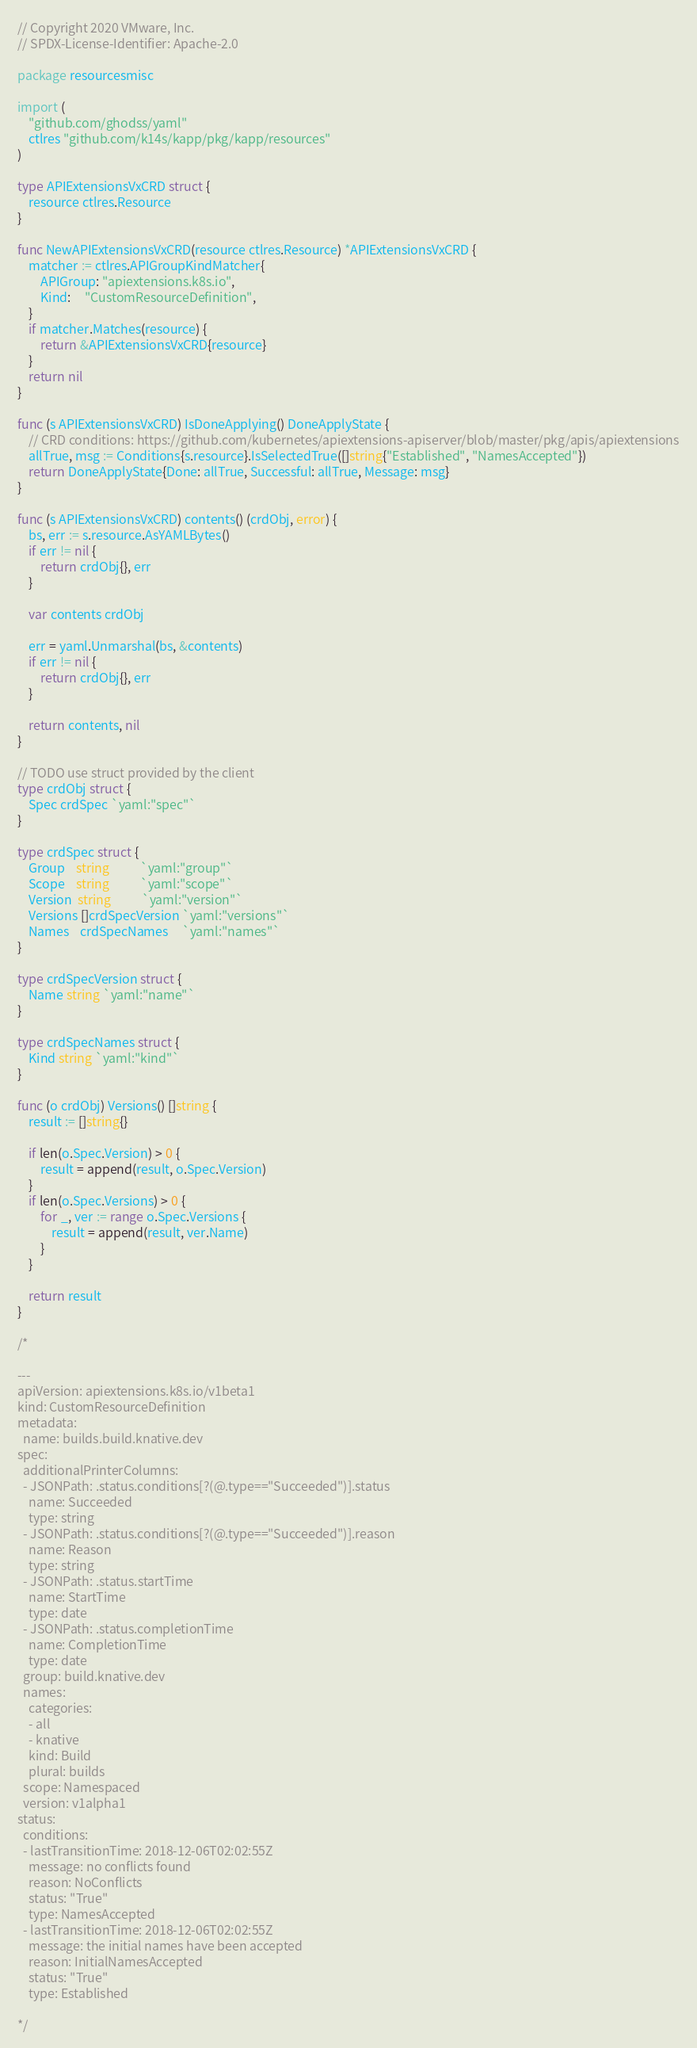Convert code to text. <code><loc_0><loc_0><loc_500><loc_500><_Go_>// Copyright 2020 VMware, Inc.
// SPDX-License-Identifier: Apache-2.0

package resourcesmisc

import (
	"github.com/ghodss/yaml"
	ctlres "github.com/k14s/kapp/pkg/kapp/resources"
)

type APIExtensionsVxCRD struct {
	resource ctlres.Resource
}

func NewAPIExtensionsVxCRD(resource ctlres.Resource) *APIExtensionsVxCRD {
	matcher := ctlres.APIGroupKindMatcher{
		APIGroup: "apiextensions.k8s.io",
		Kind:     "CustomResourceDefinition",
	}
	if matcher.Matches(resource) {
		return &APIExtensionsVxCRD{resource}
	}
	return nil
}

func (s APIExtensionsVxCRD) IsDoneApplying() DoneApplyState {
	// CRD conditions: https://github.com/kubernetes/apiextensions-apiserver/blob/master/pkg/apis/apiextensions
	allTrue, msg := Conditions{s.resource}.IsSelectedTrue([]string{"Established", "NamesAccepted"})
	return DoneApplyState{Done: allTrue, Successful: allTrue, Message: msg}
}

func (s APIExtensionsVxCRD) contents() (crdObj, error) {
	bs, err := s.resource.AsYAMLBytes()
	if err != nil {
		return crdObj{}, err
	}

	var contents crdObj

	err = yaml.Unmarshal(bs, &contents)
	if err != nil {
		return crdObj{}, err
	}

	return contents, nil
}

// TODO use struct provided by the client
type crdObj struct {
	Spec crdSpec `yaml:"spec"`
}

type crdSpec struct {
	Group    string           `yaml:"group"`
	Scope    string           `yaml:"scope"`
	Version  string           `yaml:"version"`
	Versions []crdSpecVersion `yaml:"versions"`
	Names    crdSpecNames     `yaml:"names"`
}

type crdSpecVersion struct {
	Name string `yaml:"name"`
}

type crdSpecNames struct {
	Kind string `yaml:"kind"`
}

func (o crdObj) Versions() []string {
	result := []string{}

	if len(o.Spec.Version) > 0 {
		result = append(result, o.Spec.Version)
	}
	if len(o.Spec.Versions) > 0 {
		for _, ver := range o.Spec.Versions {
			result = append(result, ver.Name)
		}
	}

	return result
}

/*

---
apiVersion: apiextensions.k8s.io/v1beta1
kind: CustomResourceDefinition
metadata:
  name: builds.build.knative.dev
spec:
  additionalPrinterColumns:
  - JSONPath: .status.conditions[?(@.type=="Succeeded")].status
    name: Succeeded
    type: string
  - JSONPath: .status.conditions[?(@.type=="Succeeded")].reason
    name: Reason
    type: string
  - JSONPath: .status.startTime
    name: StartTime
    type: date
  - JSONPath: .status.completionTime
    name: CompletionTime
    type: date
  group: build.knative.dev
  names:
    categories:
    - all
    - knative
    kind: Build
    plural: builds
  scope: Namespaced
  version: v1alpha1
status:
  conditions:
  - lastTransitionTime: 2018-12-06T02:02:55Z
    message: no conflicts found
    reason: NoConflicts
    status: "True"
    type: NamesAccepted
  - lastTransitionTime: 2018-12-06T02:02:55Z
    message: the initial names have been accepted
    reason: InitialNamesAccepted
    status: "True"
    type: Established

*/
</code> 